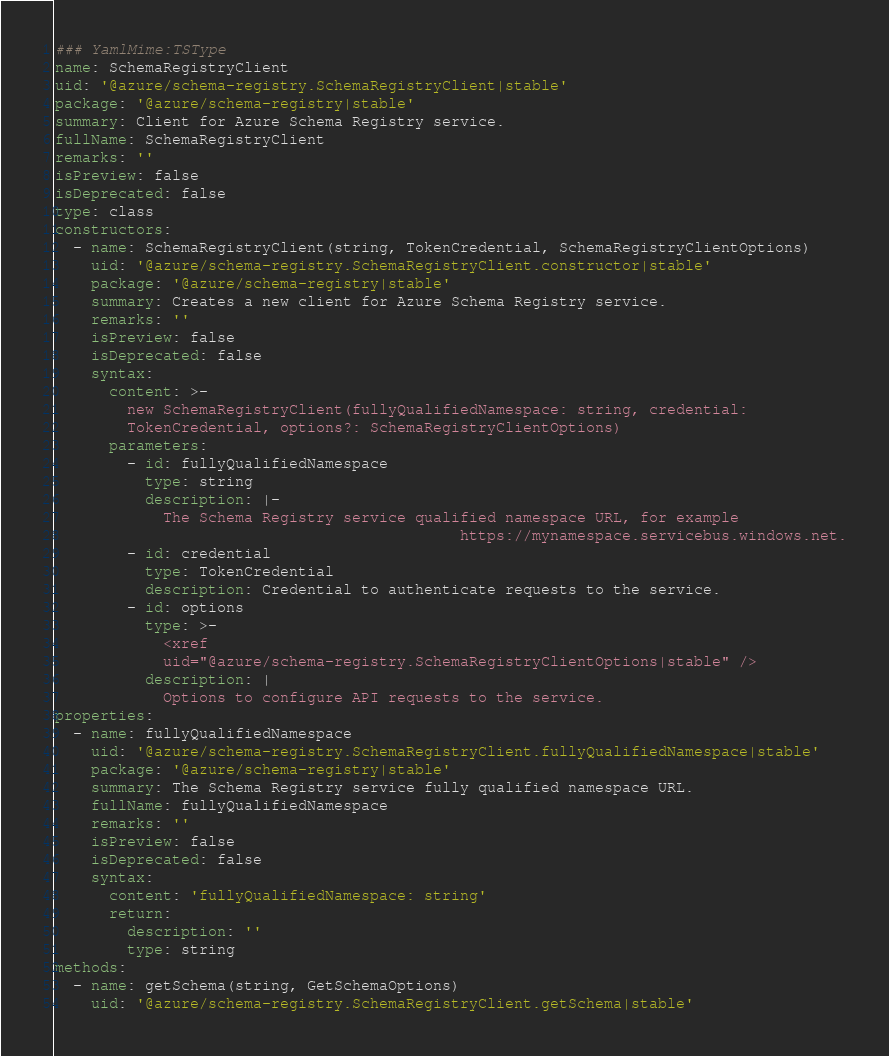Convert code to text. <code><loc_0><loc_0><loc_500><loc_500><_YAML_>### YamlMime:TSType
name: SchemaRegistryClient
uid: '@azure/schema-registry.SchemaRegistryClient|stable'
package: '@azure/schema-registry|stable'
summary: Client for Azure Schema Registry service.
fullName: SchemaRegistryClient
remarks: ''
isPreview: false
isDeprecated: false
type: class
constructors:
  - name: SchemaRegistryClient(string, TokenCredential, SchemaRegistryClientOptions)
    uid: '@azure/schema-registry.SchemaRegistryClient.constructor|stable'
    package: '@azure/schema-registry|stable'
    summary: Creates a new client for Azure Schema Registry service.
    remarks: ''
    isPreview: false
    isDeprecated: false
    syntax:
      content: >-
        new SchemaRegistryClient(fullyQualifiedNamespace: string, credential:
        TokenCredential, options?: SchemaRegistryClientOptions)
      parameters:
        - id: fullyQualifiedNamespace
          type: string
          description: |-
            The Schema Registry service qualified namespace URL, for example
                                             https://mynamespace.servicebus.windows.net.
        - id: credential
          type: TokenCredential
          description: Credential to authenticate requests to the service.
        - id: options
          type: >-
            <xref
            uid="@azure/schema-registry.SchemaRegistryClientOptions|stable" />
          description: |
            Options to configure API requests to the service.
properties:
  - name: fullyQualifiedNamespace
    uid: '@azure/schema-registry.SchemaRegistryClient.fullyQualifiedNamespace|stable'
    package: '@azure/schema-registry|stable'
    summary: The Schema Registry service fully qualified namespace URL.
    fullName: fullyQualifiedNamespace
    remarks: ''
    isPreview: false
    isDeprecated: false
    syntax:
      content: 'fullyQualifiedNamespace: string'
      return:
        description: ''
        type: string
methods:
  - name: getSchema(string, GetSchemaOptions)
    uid: '@azure/schema-registry.SchemaRegistryClient.getSchema|stable'</code> 